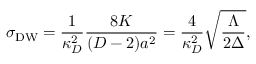Convert formula to latex. <formula><loc_0><loc_0><loc_500><loc_500>\sigma _ { D W } = { \frac { 1 } { \kappa _ { D } ^ { 2 } } } { \frac { 8 K } { ( D - 2 ) a ^ { 2 } } } = { \frac { 4 } { \kappa _ { D } ^ { 2 } } } \sqrt { \frac { \Lambda } { 2 \Delta } } ,</formula> 